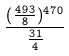<formula> <loc_0><loc_0><loc_500><loc_500>\frac { ( \frac { 4 9 3 } { 8 } ) ^ { 4 7 0 } } { \frac { 3 1 } { 4 } }</formula> 